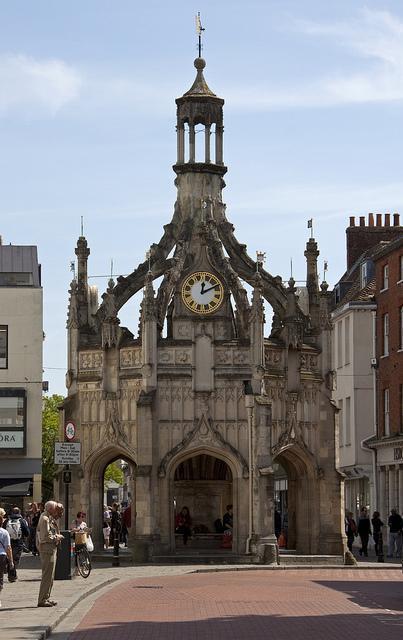Why would you look at this building?
Indicate the correct choice and explain in the format: 'Answer: answer
Rationale: rationale.'
Options: Schedule, menu, time, temperature. Answer: time.
Rationale: There is a clock on the front of it. 